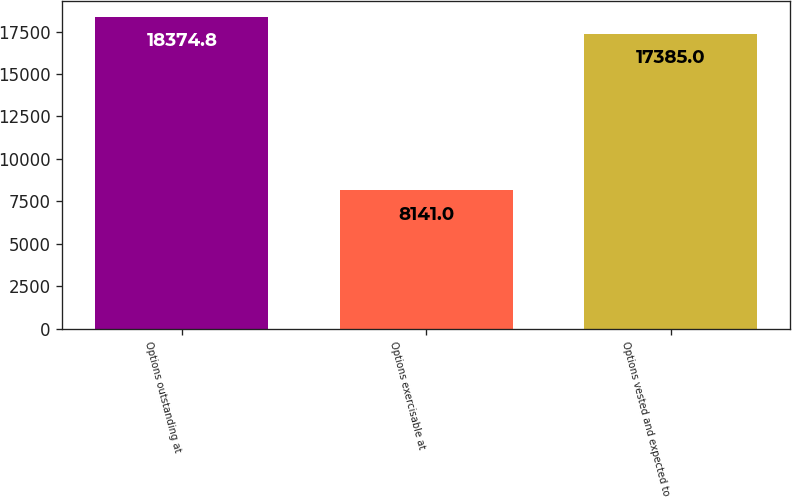Convert chart. <chart><loc_0><loc_0><loc_500><loc_500><bar_chart><fcel>Options outstanding at<fcel>Options exercisable at<fcel>Options vested and expected to<nl><fcel>18374.8<fcel>8141<fcel>17385<nl></chart> 